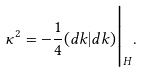Convert formula to latex. <formula><loc_0><loc_0><loc_500><loc_500>\kappa ^ { 2 } = - \frac { 1 } { 4 } ( d k | d k ) \Big | _ { H } .</formula> 